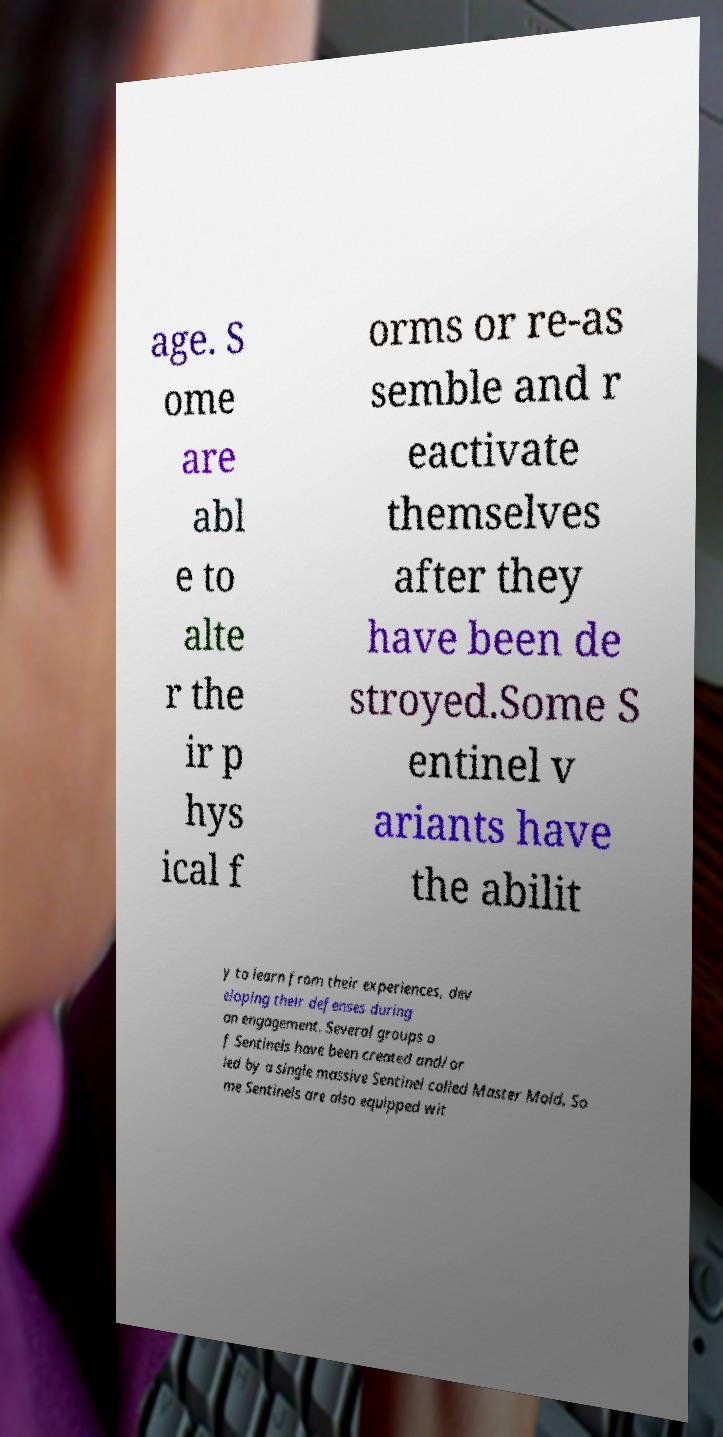Please identify and transcribe the text found in this image. age. S ome are abl e to alte r the ir p hys ical f orms or re-as semble and r eactivate themselves after they have been de stroyed.Some S entinel v ariants have the abilit y to learn from their experiences, dev eloping their defenses during an engagement. Several groups o f Sentinels have been created and/or led by a single massive Sentinel called Master Mold. So me Sentinels are also equipped wit 